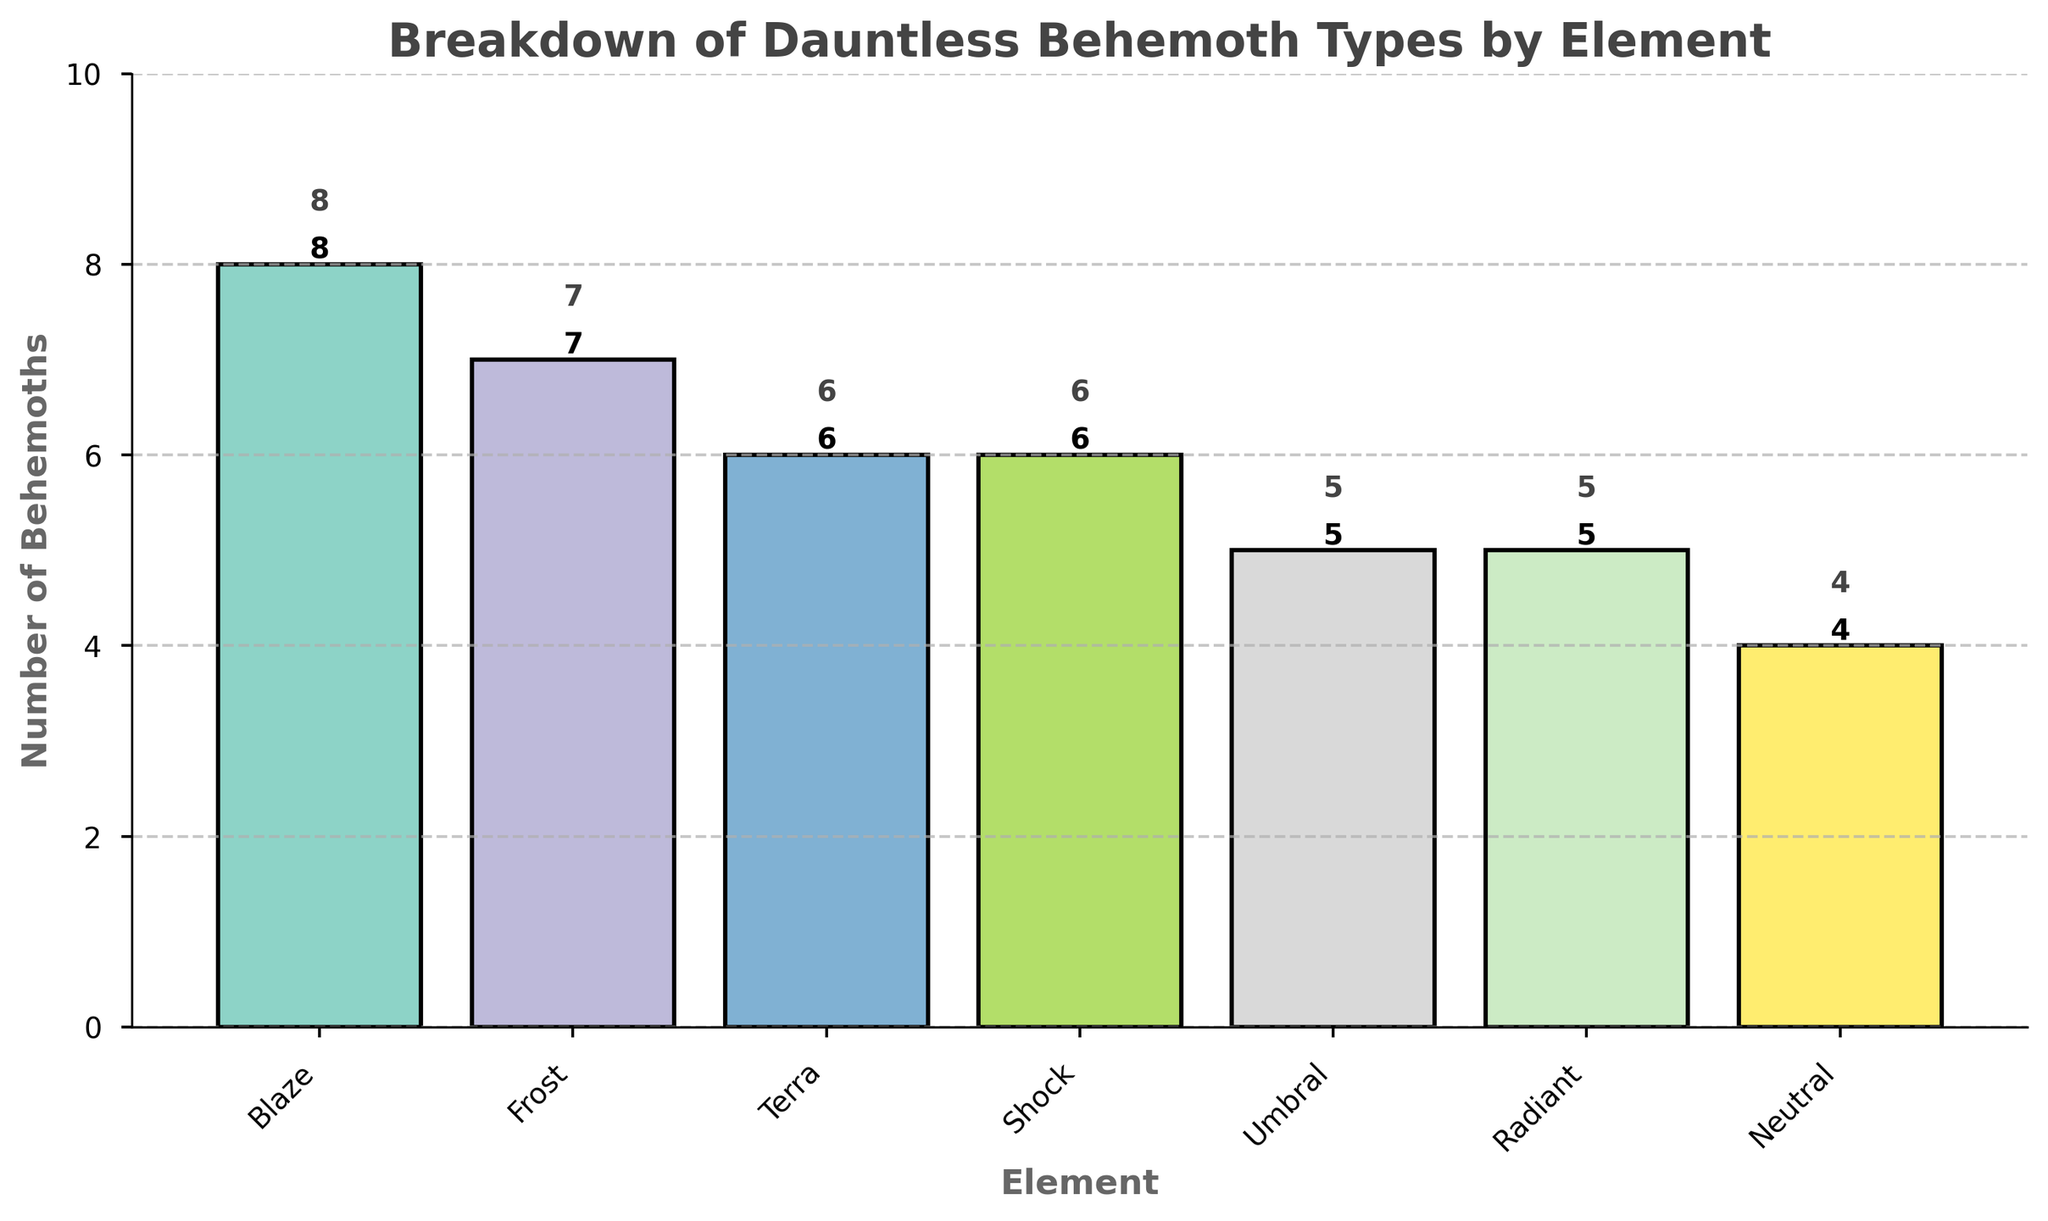How many behemoth types are categorized as 'Blaze'? According to the bar chart, the 'Blaze' category has a bar corresponding to an 8.
Answer: 8 Which element has the least number of behemoth types? The bar chart shows the 'Neutral' element with the smallest bar compared to the other elements.
Answer: Neutral What is the difference in the number of behemoth types between 'Blaze' and 'Neutral'? The 'Blaze' category has 8 behemoths and the 'Neutral' category has 4. The difference is calculated as 8 - 4 = 4.
Answer: 4 Which elements have the same number of behemoth types? The elements 'Umbral' and 'Radiant' each have 5 behemoths, as indicated by the same bar heights.
Answer: Umbral and Radiant What is the total number of behemoth types represented in the chart? Adding up all the categories: 8 (Blaze) + 7 (Frost) + 6 (Terra) + 6 (Shock) + 5 (Umbral) + 5 (Radiant) + 4 (Neutral) gives a total of 41.
Answer: 41 Do 'Terra' and 'Shock' combined have more or fewer behemoths than 'Blaze'? 'Terra' has 6 and 'Shock' also has 6, which together make 6 + 6 = 12. 'Blaze' alone has 8 behemoths. Therefore, Terra and Shock combined have more than Blaze.
Answer: More Which element category's bar is tallest? The bar representing 'Blaze' is the tallest in the chart, indicating the highest count among the elements.
Answer: Blaze What is the average number of behemoth types per element? To find the average, sum up all the counts: 8 + 7 + 6 + 6 + 5 + 5 + 4 = 41, and divide by the number of elements (7). The average is 41 / 7 ≈ 5.86.
Answer: Approximately 5.86 How many elements have more than 5 behemoth types? From the chart, the elements 'Blaze', 'Frost', 'Terra', and 'Shock' all have counts above 5. There are 4 such elements.
Answer: 4 What is the combined count for the elements that fall into the 'Neutral' category? The chart indicates that 'Neutral' category has 4 behemoth types. Therefore, the combined count for 'Neutral' is simply 4.
Answer: 4 